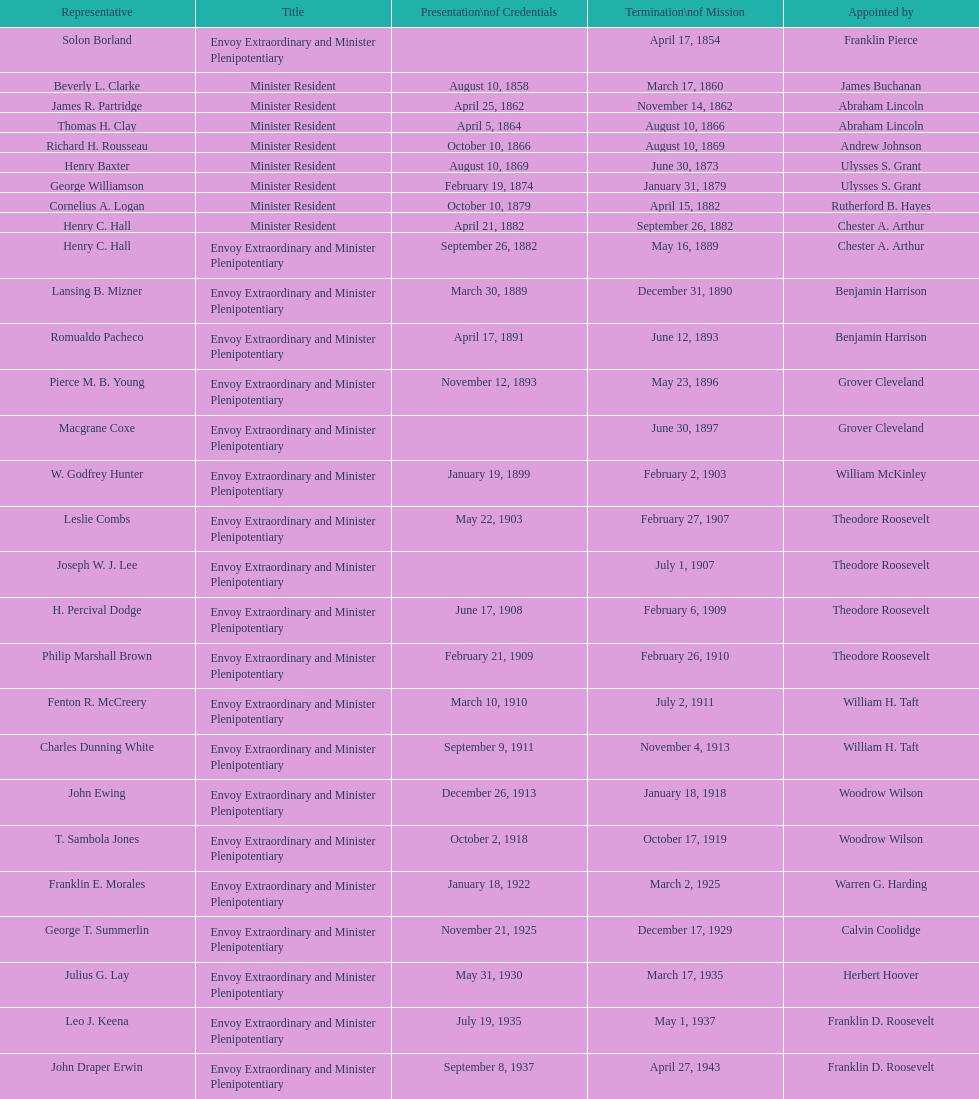Which date is below april 17, 1854 March 17, 1860. 